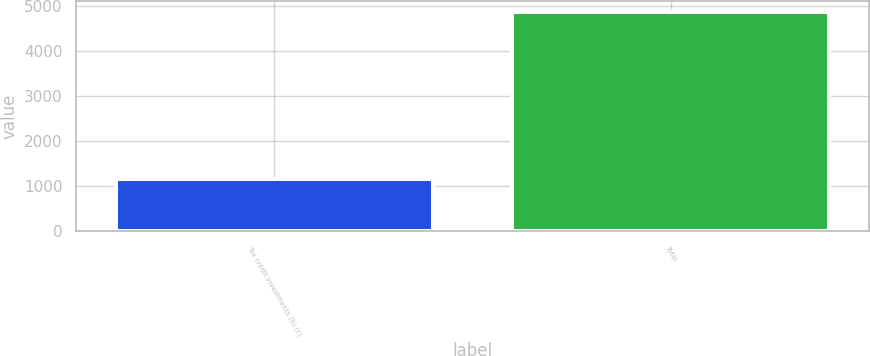<chart> <loc_0><loc_0><loc_500><loc_500><bar_chart><fcel>Tax credit investments (b) (c)<fcel>Total<nl><fcel>1156<fcel>4874<nl></chart> 